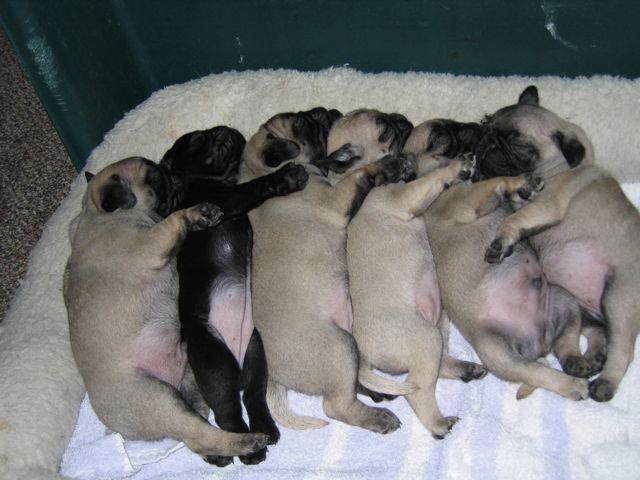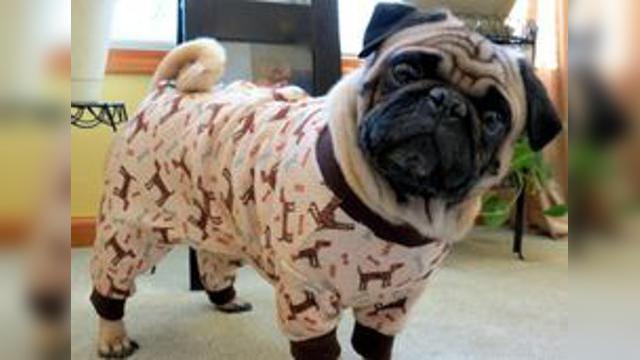The first image is the image on the left, the second image is the image on the right. Examine the images to the left and right. Is the description "Both dogs are being dressed in human like attire." accurate? Answer yes or no. No. The first image is the image on the left, the second image is the image on the right. Given the left and right images, does the statement "One image shows a horizontal row of pug dogs that are not in costume." hold true? Answer yes or no. Yes. 